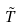Convert formula to latex. <formula><loc_0><loc_0><loc_500><loc_500>\tilde { T }</formula> 